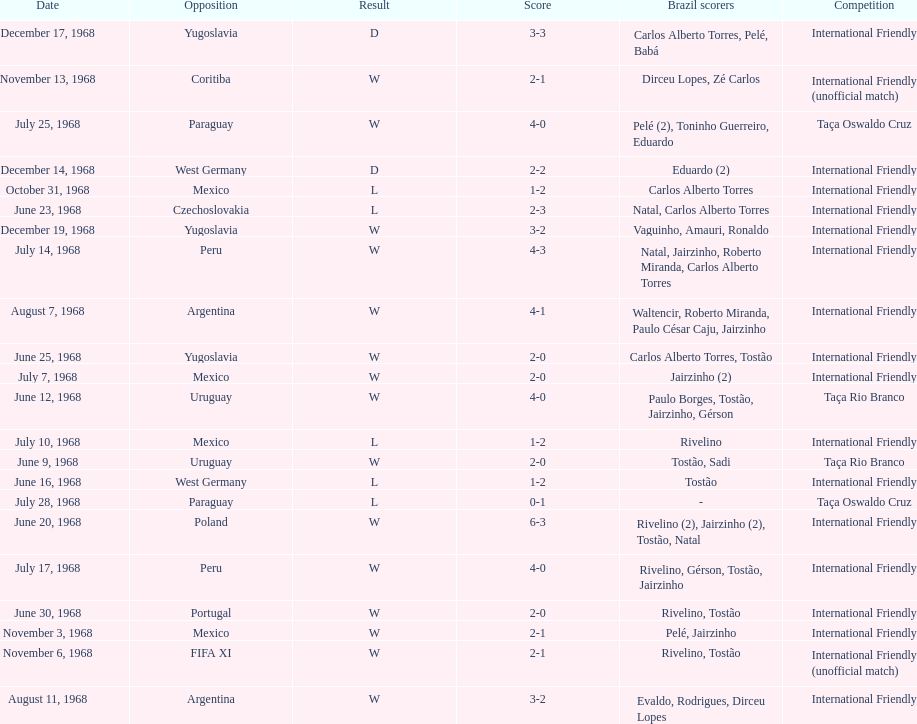Total number of wins 15. Help me parse the entirety of this table. {'header': ['Date', 'Opposition', 'Result', 'Score', 'Brazil scorers', 'Competition'], 'rows': [['December 17, 1968', 'Yugoslavia', 'D', '3-3', 'Carlos Alberto Torres, Pelé, Babá', 'International Friendly'], ['November 13, 1968', 'Coritiba', 'W', '2-1', 'Dirceu Lopes, Zé Carlos', 'International Friendly (unofficial match)'], ['July 25, 1968', 'Paraguay', 'W', '4-0', 'Pelé (2), Toninho Guerreiro, Eduardo', 'Taça Oswaldo Cruz'], ['December 14, 1968', 'West Germany', 'D', '2-2', 'Eduardo (2)', 'International Friendly'], ['October 31, 1968', 'Mexico', 'L', '1-2', 'Carlos Alberto Torres', 'International Friendly'], ['June 23, 1968', 'Czechoslovakia', 'L', '2-3', 'Natal, Carlos Alberto Torres', 'International Friendly'], ['December 19, 1968', 'Yugoslavia', 'W', '3-2', 'Vaguinho, Amauri, Ronaldo', 'International Friendly'], ['July 14, 1968', 'Peru', 'W', '4-3', 'Natal, Jairzinho, Roberto Miranda, Carlos Alberto Torres', 'International Friendly'], ['August 7, 1968', 'Argentina', 'W', '4-1', 'Waltencir, Roberto Miranda, Paulo César Caju, Jairzinho', 'International Friendly'], ['June 25, 1968', 'Yugoslavia', 'W', '2-0', 'Carlos Alberto Torres, Tostão', 'International Friendly'], ['July 7, 1968', 'Mexico', 'W', '2-0', 'Jairzinho (2)', 'International Friendly'], ['June 12, 1968', 'Uruguay', 'W', '4-0', 'Paulo Borges, Tostão, Jairzinho, Gérson', 'Taça Rio Branco'], ['July 10, 1968', 'Mexico', 'L', '1-2', 'Rivelino', 'International Friendly'], ['June 9, 1968', 'Uruguay', 'W', '2-0', 'Tostão, Sadi', 'Taça Rio Branco'], ['June 16, 1968', 'West Germany', 'L', '1-2', 'Tostão', 'International Friendly'], ['July 28, 1968', 'Paraguay', 'L', '0-1', '-', 'Taça Oswaldo Cruz'], ['June 20, 1968', 'Poland', 'W', '6-3', 'Rivelino (2), Jairzinho (2), Tostão, Natal', 'International Friendly'], ['July 17, 1968', 'Peru', 'W', '4-0', 'Rivelino, Gérson, Tostão, Jairzinho', 'International Friendly'], ['June 30, 1968', 'Portugal', 'W', '2-0', 'Rivelino, Tostão', 'International Friendly'], ['November 3, 1968', 'Mexico', 'W', '2-1', 'Pelé, Jairzinho', 'International Friendly'], ['November 6, 1968', 'FIFA XI', 'W', '2-1', 'Rivelino, Tostão', 'International Friendly (unofficial match)'], ['August 11, 1968', 'Argentina', 'W', '3-2', 'Evaldo, Rodrigues, Dirceu Lopes', 'International Friendly']]} 